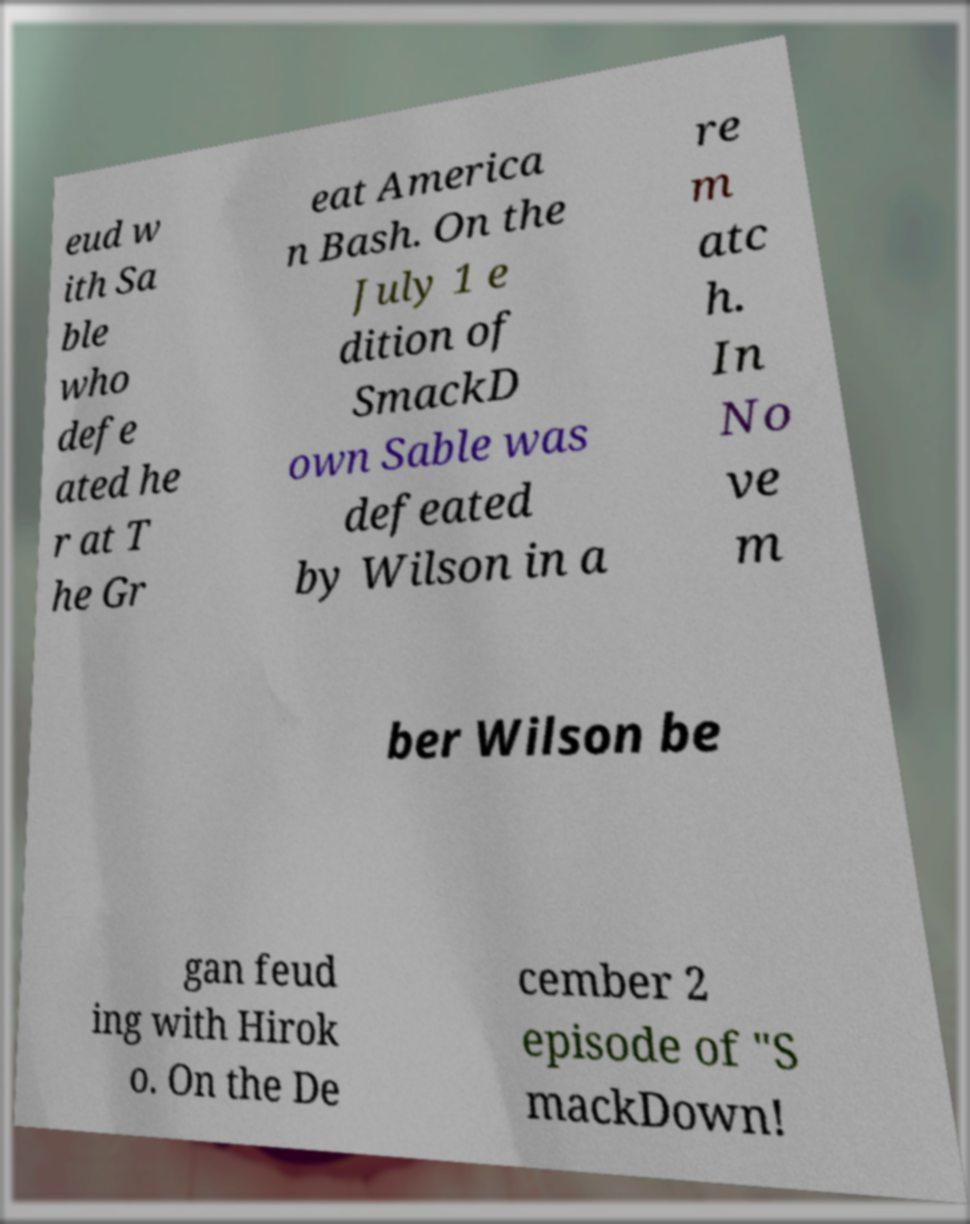I need the written content from this picture converted into text. Can you do that? eud w ith Sa ble who defe ated he r at T he Gr eat America n Bash. On the July 1 e dition of SmackD own Sable was defeated by Wilson in a re m atc h. In No ve m ber Wilson be gan feud ing with Hirok o. On the De cember 2 episode of "S mackDown! 